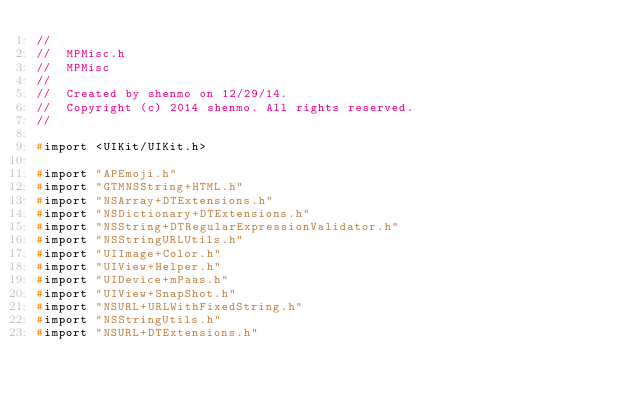Convert code to text. <code><loc_0><loc_0><loc_500><loc_500><_C_>//
//  MPMisc.h
//  MPMisc
//
//  Created by shenmo on 12/29/14.
//  Copyright (c) 2014 shenmo. All rights reserved.
//

#import <UIKit/UIKit.h>

#import "APEmoji.h"
#import "GTMNSString+HTML.h"
#import "NSArray+DTExtensions.h"
#import "NSDictionary+DTExtensions.h"
#import "NSString+DTRegularExpressionValidator.h"
#import "NSStringURLUtils.h"
#import "UIImage+Color.h"
#import "UIView+Helper.h"
#import "UIDevice+mPaas.h"
#import "UIView+SnapShot.h"
#import "NSURL+URLWithFixedString.h"
#import "NSStringUtils.h"
#import "NSURL+DTExtensions.h"

</code> 